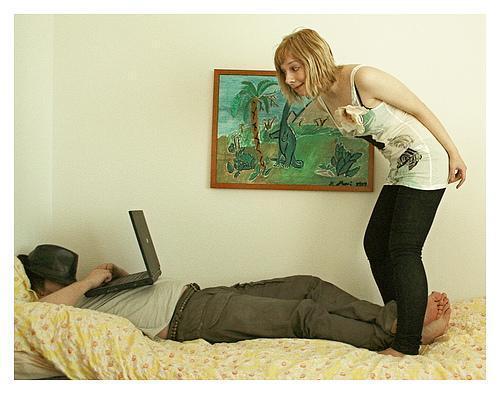How many people are shown?
Give a very brief answer. 2. How many people are there?
Give a very brief answer. 2. How many motorcycles are parked off the street?
Give a very brief answer. 0. 